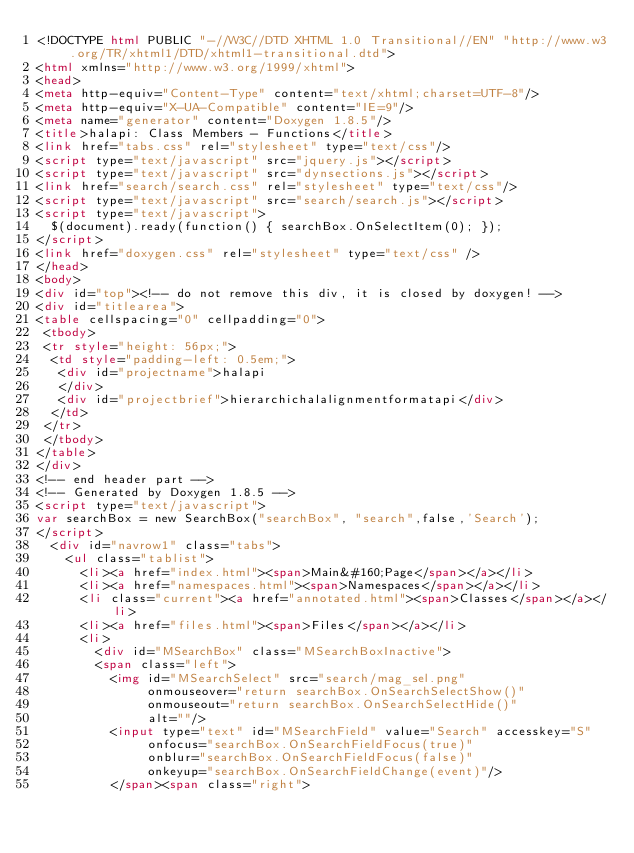<code> <loc_0><loc_0><loc_500><loc_500><_HTML_><!DOCTYPE html PUBLIC "-//W3C//DTD XHTML 1.0 Transitional//EN" "http://www.w3.org/TR/xhtml1/DTD/xhtml1-transitional.dtd">
<html xmlns="http://www.w3.org/1999/xhtml">
<head>
<meta http-equiv="Content-Type" content="text/xhtml;charset=UTF-8"/>
<meta http-equiv="X-UA-Compatible" content="IE=9"/>
<meta name="generator" content="Doxygen 1.8.5"/>
<title>halapi: Class Members - Functions</title>
<link href="tabs.css" rel="stylesheet" type="text/css"/>
<script type="text/javascript" src="jquery.js"></script>
<script type="text/javascript" src="dynsections.js"></script>
<link href="search/search.css" rel="stylesheet" type="text/css"/>
<script type="text/javascript" src="search/search.js"></script>
<script type="text/javascript">
  $(document).ready(function() { searchBox.OnSelectItem(0); });
</script>
<link href="doxygen.css" rel="stylesheet" type="text/css" />
</head>
<body>
<div id="top"><!-- do not remove this div, it is closed by doxygen! -->
<div id="titlearea">
<table cellspacing="0" cellpadding="0">
 <tbody>
 <tr style="height: 56px;">
  <td style="padding-left: 0.5em;">
   <div id="projectname">halapi
   </div>
   <div id="projectbrief">hierarchichalalignmentformatapi</div>
  </td>
 </tr>
 </tbody>
</table>
</div>
<!-- end header part -->
<!-- Generated by Doxygen 1.8.5 -->
<script type="text/javascript">
var searchBox = new SearchBox("searchBox", "search",false,'Search');
</script>
  <div id="navrow1" class="tabs">
    <ul class="tablist">
      <li><a href="index.html"><span>Main&#160;Page</span></a></li>
      <li><a href="namespaces.html"><span>Namespaces</span></a></li>
      <li class="current"><a href="annotated.html"><span>Classes</span></a></li>
      <li><a href="files.html"><span>Files</span></a></li>
      <li>
        <div id="MSearchBox" class="MSearchBoxInactive">
        <span class="left">
          <img id="MSearchSelect" src="search/mag_sel.png"
               onmouseover="return searchBox.OnSearchSelectShow()"
               onmouseout="return searchBox.OnSearchSelectHide()"
               alt=""/>
          <input type="text" id="MSearchField" value="Search" accesskey="S"
               onfocus="searchBox.OnSearchFieldFocus(true)" 
               onblur="searchBox.OnSearchFieldFocus(false)" 
               onkeyup="searchBox.OnSearchFieldChange(event)"/>
          </span><span class="right"></code> 